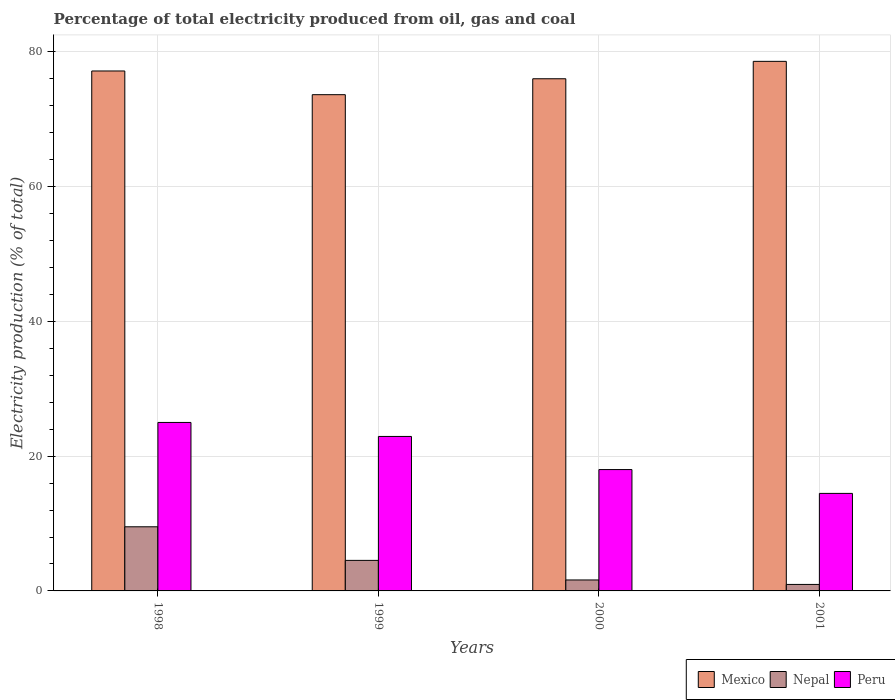How many groups of bars are there?
Keep it short and to the point. 4. What is the label of the 1st group of bars from the left?
Provide a succinct answer. 1998. In how many cases, is the number of bars for a given year not equal to the number of legend labels?
Your response must be concise. 0. What is the electricity production in in Peru in 1999?
Provide a succinct answer. 22.93. Across all years, what is the maximum electricity production in in Mexico?
Give a very brief answer. 78.61. Across all years, what is the minimum electricity production in in Mexico?
Ensure brevity in your answer.  73.66. In which year was the electricity production in in Mexico maximum?
Offer a terse response. 2001. In which year was the electricity production in in Mexico minimum?
Your response must be concise. 1999. What is the total electricity production in in Nepal in the graph?
Offer a terse response. 16.64. What is the difference between the electricity production in in Nepal in 1999 and that in 2000?
Offer a terse response. 2.91. What is the difference between the electricity production in in Mexico in 1998 and the electricity production in in Peru in 2001?
Your response must be concise. 62.7. What is the average electricity production in in Peru per year?
Provide a succinct answer. 20.11. In the year 2000, what is the difference between the electricity production in in Nepal and electricity production in in Peru?
Make the answer very short. -16.38. What is the ratio of the electricity production in in Mexico in 1998 to that in 1999?
Your response must be concise. 1.05. Is the electricity production in in Peru in 1998 less than that in 2001?
Your answer should be very brief. No. What is the difference between the highest and the second highest electricity production in in Nepal?
Your response must be concise. 4.99. What is the difference between the highest and the lowest electricity production in in Nepal?
Give a very brief answer. 8.56. What does the 1st bar from the left in 1999 represents?
Make the answer very short. Mexico. What does the 2nd bar from the right in 1999 represents?
Provide a succinct answer. Nepal. Is it the case that in every year, the sum of the electricity production in in Nepal and electricity production in in Peru is greater than the electricity production in in Mexico?
Your answer should be compact. No. Are all the bars in the graph horizontal?
Your answer should be compact. No. How many years are there in the graph?
Give a very brief answer. 4. What is the difference between two consecutive major ticks on the Y-axis?
Your answer should be compact. 20. Are the values on the major ticks of Y-axis written in scientific E-notation?
Offer a terse response. No. Does the graph contain grids?
Offer a terse response. Yes. Where does the legend appear in the graph?
Give a very brief answer. Bottom right. What is the title of the graph?
Your response must be concise. Percentage of total electricity produced from oil, gas and coal. What is the label or title of the Y-axis?
Give a very brief answer. Electricity production (% of total). What is the Electricity production (% of total) in Mexico in 1998?
Give a very brief answer. 77.18. What is the Electricity production (% of total) of Nepal in 1998?
Make the answer very short. 9.52. What is the Electricity production (% of total) of Peru in 1998?
Keep it short and to the point. 25.01. What is the Electricity production (% of total) in Mexico in 1999?
Provide a succinct answer. 73.66. What is the Electricity production (% of total) in Nepal in 1999?
Offer a terse response. 4.53. What is the Electricity production (% of total) of Peru in 1999?
Your answer should be compact. 22.93. What is the Electricity production (% of total) of Mexico in 2000?
Offer a terse response. 76.02. What is the Electricity production (% of total) of Nepal in 2000?
Offer a very short reply. 1.63. What is the Electricity production (% of total) in Peru in 2000?
Your answer should be compact. 18.01. What is the Electricity production (% of total) in Mexico in 2001?
Keep it short and to the point. 78.61. What is the Electricity production (% of total) of Nepal in 2001?
Your answer should be very brief. 0.96. What is the Electricity production (% of total) of Peru in 2001?
Provide a succinct answer. 14.48. Across all years, what is the maximum Electricity production (% of total) of Mexico?
Ensure brevity in your answer.  78.61. Across all years, what is the maximum Electricity production (% of total) of Nepal?
Make the answer very short. 9.52. Across all years, what is the maximum Electricity production (% of total) in Peru?
Your answer should be very brief. 25.01. Across all years, what is the minimum Electricity production (% of total) of Mexico?
Provide a short and direct response. 73.66. Across all years, what is the minimum Electricity production (% of total) in Nepal?
Provide a succinct answer. 0.96. Across all years, what is the minimum Electricity production (% of total) of Peru?
Your response must be concise. 14.48. What is the total Electricity production (% of total) of Mexico in the graph?
Offer a very short reply. 305.47. What is the total Electricity production (% of total) in Nepal in the graph?
Keep it short and to the point. 16.64. What is the total Electricity production (% of total) in Peru in the graph?
Provide a succinct answer. 80.43. What is the difference between the Electricity production (% of total) in Mexico in 1998 and that in 1999?
Keep it short and to the point. 3.52. What is the difference between the Electricity production (% of total) of Nepal in 1998 and that in 1999?
Make the answer very short. 4.99. What is the difference between the Electricity production (% of total) of Peru in 1998 and that in 1999?
Provide a short and direct response. 2.08. What is the difference between the Electricity production (% of total) of Mexico in 1998 and that in 2000?
Your answer should be compact. 1.15. What is the difference between the Electricity production (% of total) in Nepal in 1998 and that in 2000?
Give a very brief answer. 7.89. What is the difference between the Electricity production (% of total) in Peru in 1998 and that in 2000?
Your response must be concise. 6.99. What is the difference between the Electricity production (% of total) in Mexico in 1998 and that in 2001?
Your answer should be very brief. -1.43. What is the difference between the Electricity production (% of total) in Nepal in 1998 and that in 2001?
Provide a short and direct response. 8.56. What is the difference between the Electricity production (% of total) of Peru in 1998 and that in 2001?
Give a very brief answer. 10.53. What is the difference between the Electricity production (% of total) of Mexico in 1999 and that in 2000?
Your response must be concise. -2.37. What is the difference between the Electricity production (% of total) of Nepal in 1999 and that in 2000?
Ensure brevity in your answer.  2.91. What is the difference between the Electricity production (% of total) in Peru in 1999 and that in 2000?
Your answer should be compact. 4.92. What is the difference between the Electricity production (% of total) of Mexico in 1999 and that in 2001?
Ensure brevity in your answer.  -4.95. What is the difference between the Electricity production (% of total) in Nepal in 1999 and that in 2001?
Keep it short and to the point. 3.57. What is the difference between the Electricity production (% of total) in Peru in 1999 and that in 2001?
Your response must be concise. 8.45. What is the difference between the Electricity production (% of total) in Mexico in 2000 and that in 2001?
Ensure brevity in your answer.  -2.58. What is the difference between the Electricity production (% of total) of Nepal in 2000 and that in 2001?
Ensure brevity in your answer.  0.66. What is the difference between the Electricity production (% of total) in Peru in 2000 and that in 2001?
Your answer should be compact. 3.54. What is the difference between the Electricity production (% of total) in Mexico in 1998 and the Electricity production (% of total) in Nepal in 1999?
Keep it short and to the point. 72.65. What is the difference between the Electricity production (% of total) in Mexico in 1998 and the Electricity production (% of total) in Peru in 1999?
Your answer should be compact. 54.25. What is the difference between the Electricity production (% of total) in Nepal in 1998 and the Electricity production (% of total) in Peru in 1999?
Ensure brevity in your answer.  -13.41. What is the difference between the Electricity production (% of total) in Mexico in 1998 and the Electricity production (% of total) in Nepal in 2000?
Your answer should be very brief. 75.55. What is the difference between the Electricity production (% of total) in Mexico in 1998 and the Electricity production (% of total) in Peru in 2000?
Your answer should be compact. 59.17. What is the difference between the Electricity production (% of total) of Nepal in 1998 and the Electricity production (% of total) of Peru in 2000?
Your response must be concise. -8.49. What is the difference between the Electricity production (% of total) of Mexico in 1998 and the Electricity production (% of total) of Nepal in 2001?
Your answer should be compact. 76.21. What is the difference between the Electricity production (% of total) in Mexico in 1998 and the Electricity production (% of total) in Peru in 2001?
Your answer should be very brief. 62.7. What is the difference between the Electricity production (% of total) in Nepal in 1998 and the Electricity production (% of total) in Peru in 2001?
Offer a very short reply. -4.96. What is the difference between the Electricity production (% of total) of Mexico in 1999 and the Electricity production (% of total) of Nepal in 2000?
Provide a succinct answer. 72.03. What is the difference between the Electricity production (% of total) in Mexico in 1999 and the Electricity production (% of total) in Peru in 2000?
Give a very brief answer. 55.65. What is the difference between the Electricity production (% of total) of Nepal in 1999 and the Electricity production (% of total) of Peru in 2000?
Provide a succinct answer. -13.48. What is the difference between the Electricity production (% of total) of Mexico in 1999 and the Electricity production (% of total) of Nepal in 2001?
Keep it short and to the point. 72.69. What is the difference between the Electricity production (% of total) in Mexico in 1999 and the Electricity production (% of total) in Peru in 2001?
Offer a very short reply. 59.18. What is the difference between the Electricity production (% of total) in Nepal in 1999 and the Electricity production (% of total) in Peru in 2001?
Ensure brevity in your answer.  -9.94. What is the difference between the Electricity production (% of total) in Mexico in 2000 and the Electricity production (% of total) in Nepal in 2001?
Your answer should be very brief. 75.06. What is the difference between the Electricity production (% of total) in Mexico in 2000 and the Electricity production (% of total) in Peru in 2001?
Provide a succinct answer. 61.55. What is the difference between the Electricity production (% of total) of Nepal in 2000 and the Electricity production (% of total) of Peru in 2001?
Keep it short and to the point. -12.85. What is the average Electricity production (% of total) of Mexico per year?
Your answer should be very brief. 76.37. What is the average Electricity production (% of total) in Nepal per year?
Keep it short and to the point. 4.16. What is the average Electricity production (% of total) in Peru per year?
Offer a very short reply. 20.11. In the year 1998, what is the difference between the Electricity production (% of total) of Mexico and Electricity production (% of total) of Nepal?
Provide a succinct answer. 67.66. In the year 1998, what is the difference between the Electricity production (% of total) of Mexico and Electricity production (% of total) of Peru?
Make the answer very short. 52.17. In the year 1998, what is the difference between the Electricity production (% of total) of Nepal and Electricity production (% of total) of Peru?
Provide a short and direct response. -15.49. In the year 1999, what is the difference between the Electricity production (% of total) of Mexico and Electricity production (% of total) of Nepal?
Ensure brevity in your answer.  69.13. In the year 1999, what is the difference between the Electricity production (% of total) of Mexico and Electricity production (% of total) of Peru?
Make the answer very short. 50.73. In the year 1999, what is the difference between the Electricity production (% of total) of Nepal and Electricity production (% of total) of Peru?
Your answer should be compact. -18.4. In the year 2000, what is the difference between the Electricity production (% of total) of Mexico and Electricity production (% of total) of Nepal?
Your answer should be very brief. 74.4. In the year 2000, what is the difference between the Electricity production (% of total) in Mexico and Electricity production (% of total) in Peru?
Your answer should be compact. 58.01. In the year 2000, what is the difference between the Electricity production (% of total) in Nepal and Electricity production (% of total) in Peru?
Your response must be concise. -16.39. In the year 2001, what is the difference between the Electricity production (% of total) of Mexico and Electricity production (% of total) of Nepal?
Your answer should be compact. 77.64. In the year 2001, what is the difference between the Electricity production (% of total) of Mexico and Electricity production (% of total) of Peru?
Keep it short and to the point. 64.13. In the year 2001, what is the difference between the Electricity production (% of total) of Nepal and Electricity production (% of total) of Peru?
Offer a terse response. -13.51. What is the ratio of the Electricity production (% of total) in Mexico in 1998 to that in 1999?
Ensure brevity in your answer.  1.05. What is the ratio of the Electricity production (% of total) in Nepal in 1998 to that in 1999?
Give a very brief answer. 2.1. What is the ratio of the Electricity production (% of total) of Peru in 1998 to that in 1999?
Give a very brief answer. 1.09. What is the ratio of the Electricity production (% of total) in Mexico in 1998 to that in 2000?
Your response must be concise. 1.02. What is the ratio of the Electricity production (% of total) in Nepal in 1998 to that in 2000?
Provide a short and direct response. 5.85. What is the ratio of the Electricity production (% of total) of Peru in 1998 to that in 2000?
Offer a terse response. 1.39. What is the ratio of the Electricity production (% of total) in Mexico in 1998 to that in 2001?
Your answer should be compact. 0.98. What is the ratio of the Electricity production (% of total) in Nepal in 1998 to that in 2001?
Keep it short and to the point. 9.87. What is the ratio of the Electricity production (% of total) in Peru in 1998 to that in 2001?
Offer a very short reply. 1.73. What is the ratio of the Electricity production (% of total) in Mexico in 1999 to that in 2000?
Your answer should be compact. 0.97. What is the ratio of the Electricity production (% of total) in Nepal in 1999 to that in 2000?
Make the answer very short. 2.79. What is the ratio of the Electricity production (% of total) in Peru in 1999 to that in 2000?
Your answer should be compact. 1.27. What is the ratio of the Electricity production (% of total) in Mexico in 1999 to that in 2001?
Your answer should be compact. 0.94. What is the ratio of the Electricity production (% of total) of Nepal in 1999 to that in 2001?
Offer a terse response. 4.7. What is the ratio of the Electricity production (% of total) of Peru in 1999 to that in 2001?
Keep it short and to the point. 1.58. What is the ratio of the Electricity production (% of total) of Mexico in 2000 to that in 2001?
Offer a very short reply. 0.97. What is the ratio of the Electricity production (% of total) in Nepal in 2000 to that in 2001?
Provide a short and direct response. 1.69. What is the ratio of the Electricity production (% of total) of Peru in 2000 to that in 2001?
Make the answer very short. 1.24. What is the difference between the highest and the second highest Electricity production (% of total) in Mexico?
Make the answer very short. 1.43. What is the difference between the highest and the second highest Electricity production (% of total) in Nepal?
Offer a terse response. 4.99. What is the difference between the highest and the second highest Electricity production (% of total) in Peru?
Your answer should be very brief. 2.08. What is the difference between the highest and the lowest Electricity production (% of total) in Mexico?
Your answer should be compact. 4.95. What is the difference between the highest and the lowest Electricity production (% of total) in Nepal?
Offer a terse response. 8.56. What is the difference between the highest and the lowest Electricity production (% of total) of Peru?
Offer a terse response. 10.53. 